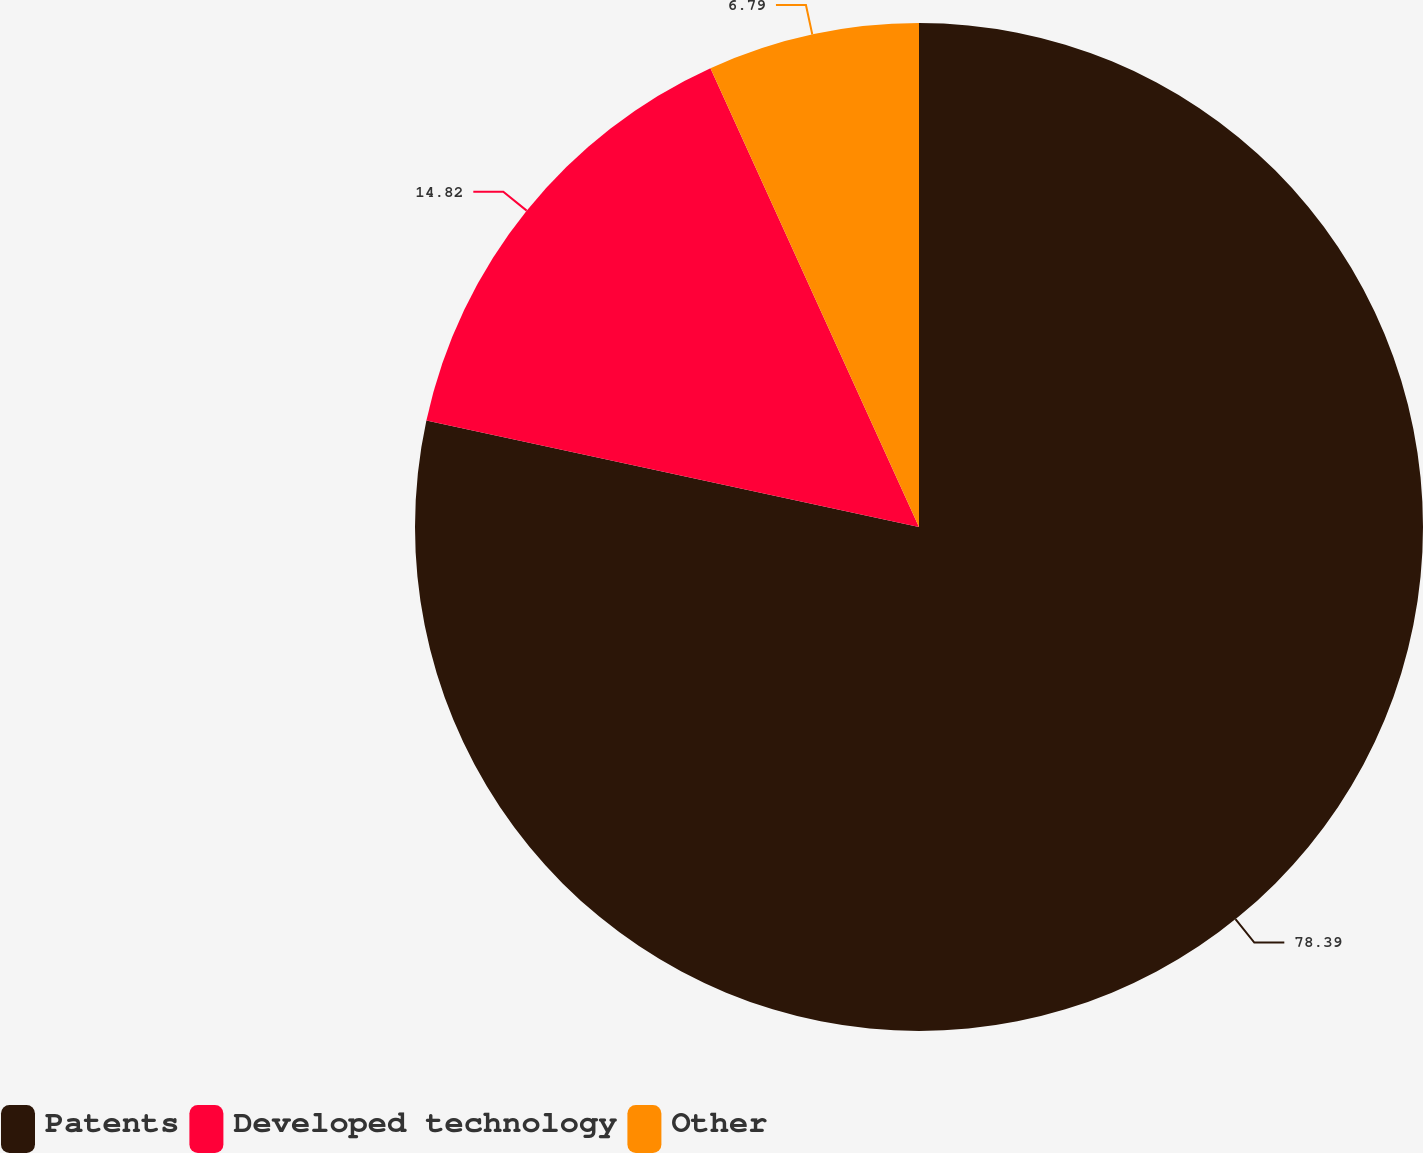Convert chart. <chart><loc_0><loc_0><loc_500><loc_500><pie_chart><fcel>Patents<fcel>Developed technology<fcel>Other<nl><fcel>78.39%<fcel>14.82%<fcel>6.79%<nl></chart> 